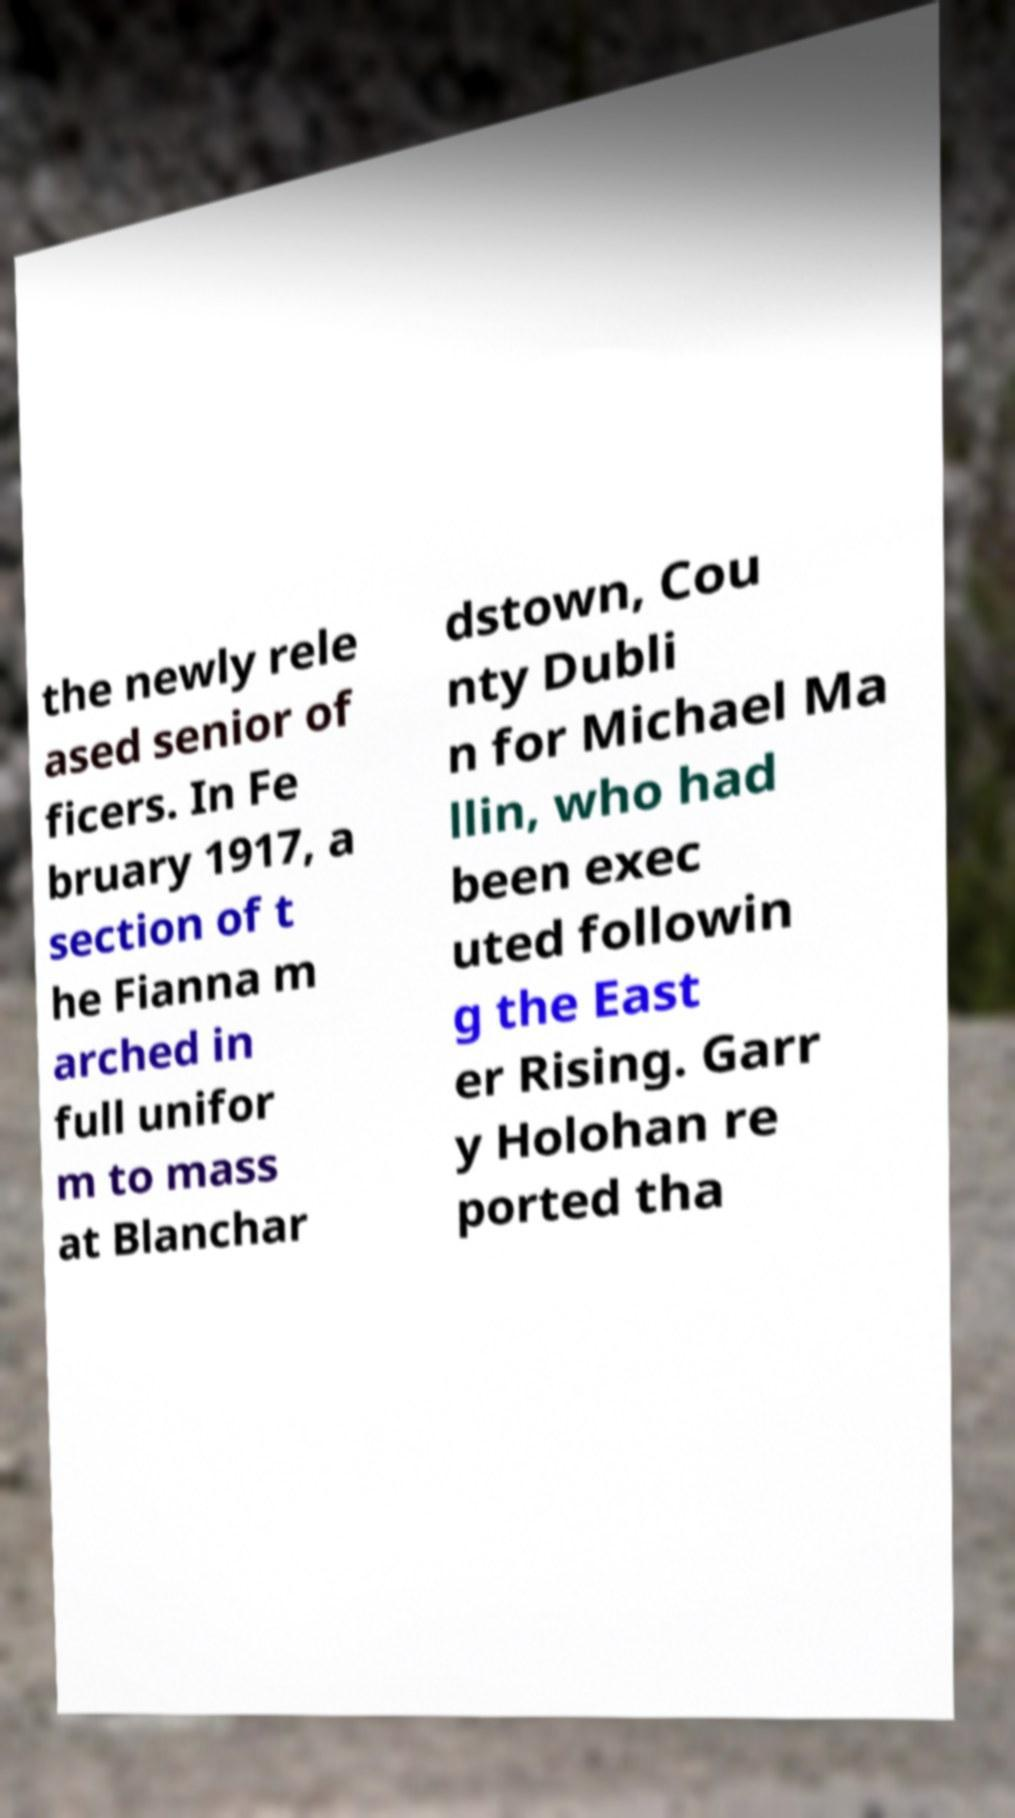Could you assist in decoding the text presented in this image and type it out clearly? the newly rele ased senior of ficers. In Fe bruary 1917, a section of t he Fianna m arched in full unifor m to mass at Blanchar dstown, Cou nty Dubli n for Michael Ma llin, who had been exec uted followin g the East er Rising. Garr y Holohan re ported tha 